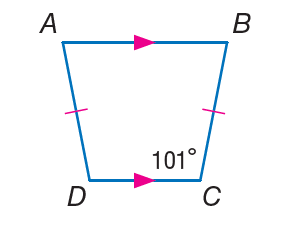Answer the mathemtical geometry problem and directly provide the correct option letter.
Question: Find m \angle D.
Choices: A: 45 B: 79 C: 101 D: 182 C 